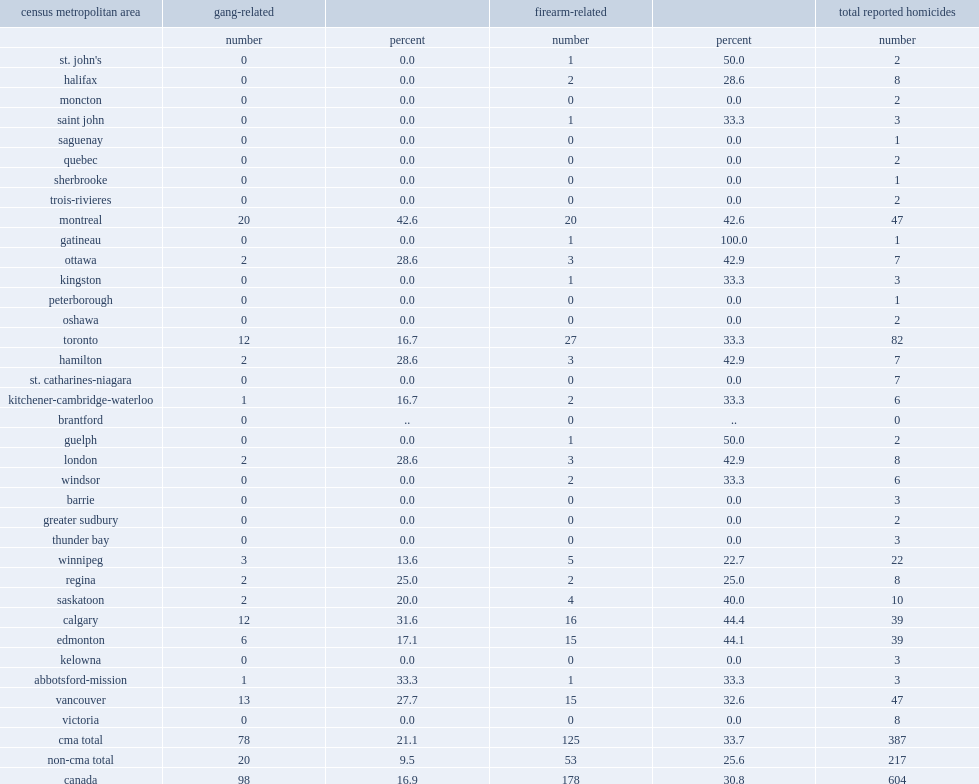List the cmas reported the majority of firearm-related homicides and numbers respectively. Toronto calgary edmonton vancouver. List the cmas reported the majority of gang-related homicides and numbers respectively. Montreal vancouver toronto calgary. 